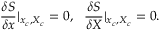<formula> <loc_0><loc_0><loc_500><loc_500>\frac { \delta S } { \delta x } | _ { x _ { c } , X _ { c } } = 0 , \quad f r a c { \delta S } { \delta X } | _ { x _ { c } , X _ { c } } = 0 .</formula> 